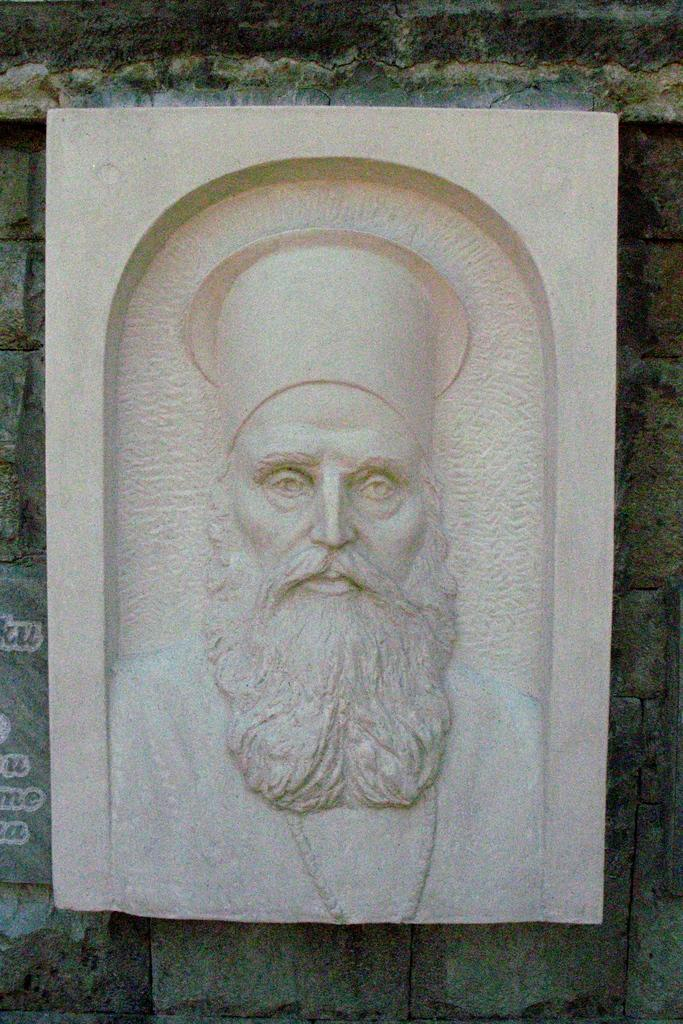What is depicted on the stone in the image? There is a man's picture engraved on the stone. What facial hair does the man have? The man has a beard and a mustache. What is the man wearing around his neck? There is a chain around the man's neck. What can be seen in the background of the image? There is a wall in the background of the image. What type of trousers is the expert wearing in the image? There is no expert or trousers present in the image; it features a man's picture engraved on a stone. 